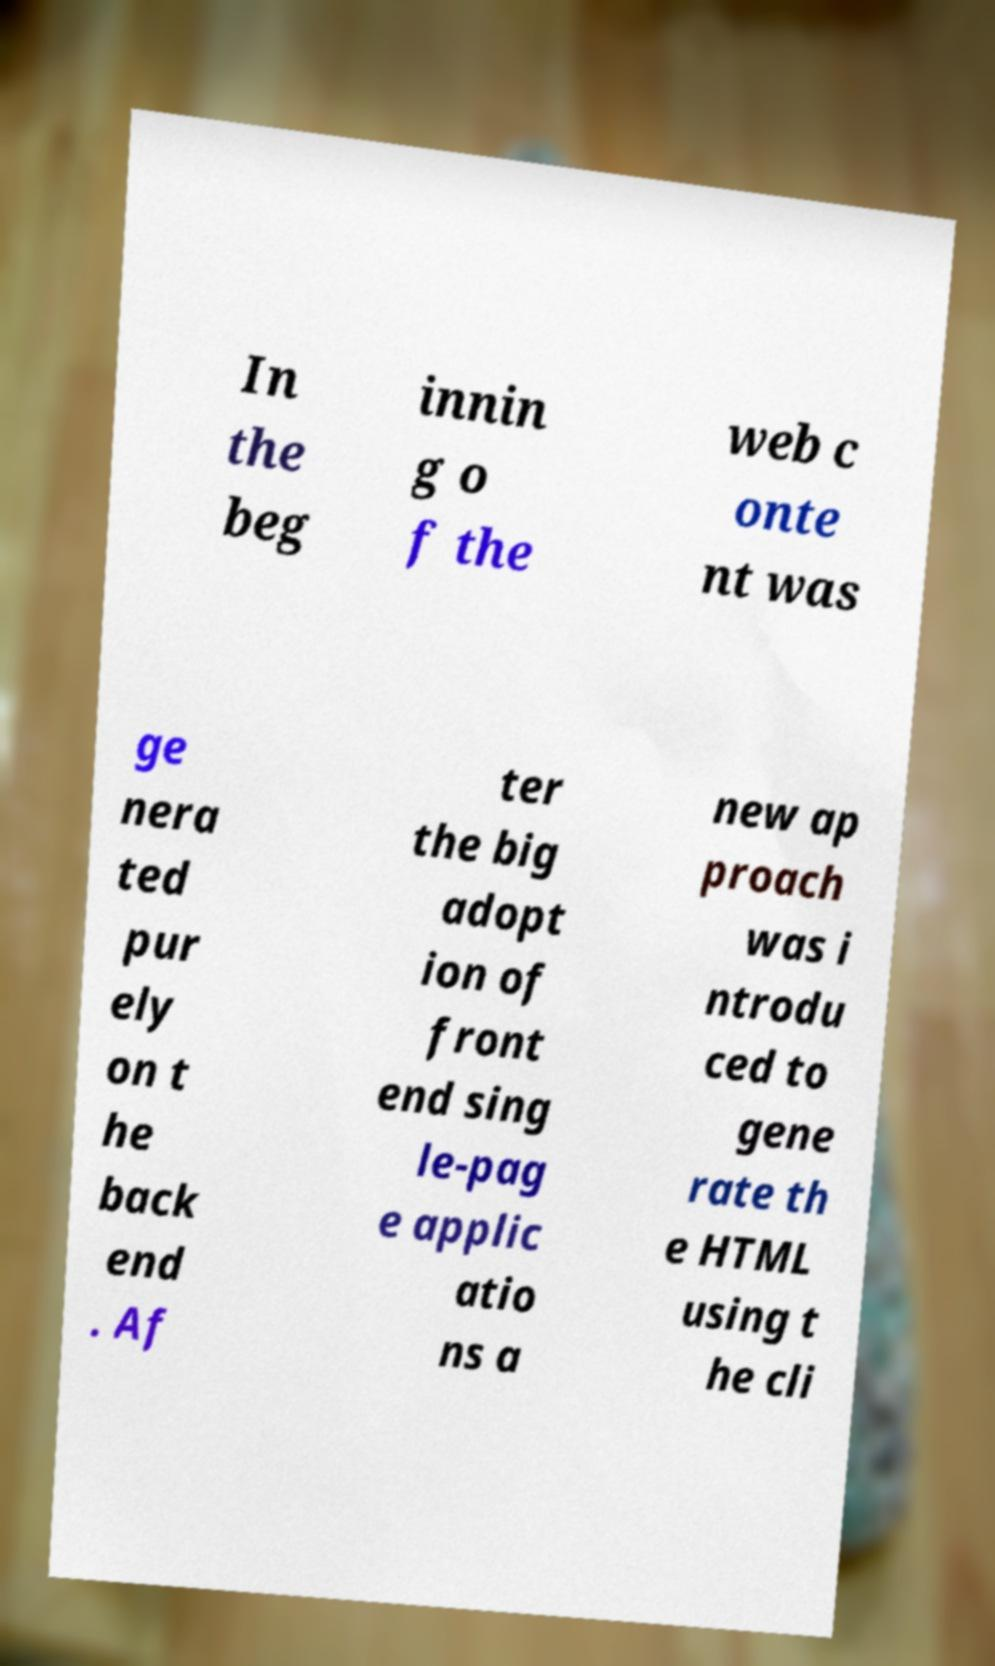For documentation purposes, I need the text within this image transcribed. Could you provide that? In the beg innin g o f the web c onte nt was ge nera ted pur ely on t he back end . Af ter the big adopt ion of front end sing le-pag e applic atio ns a new ap proach was i ntrodu ced to gene rate th e HTML using t he cli 